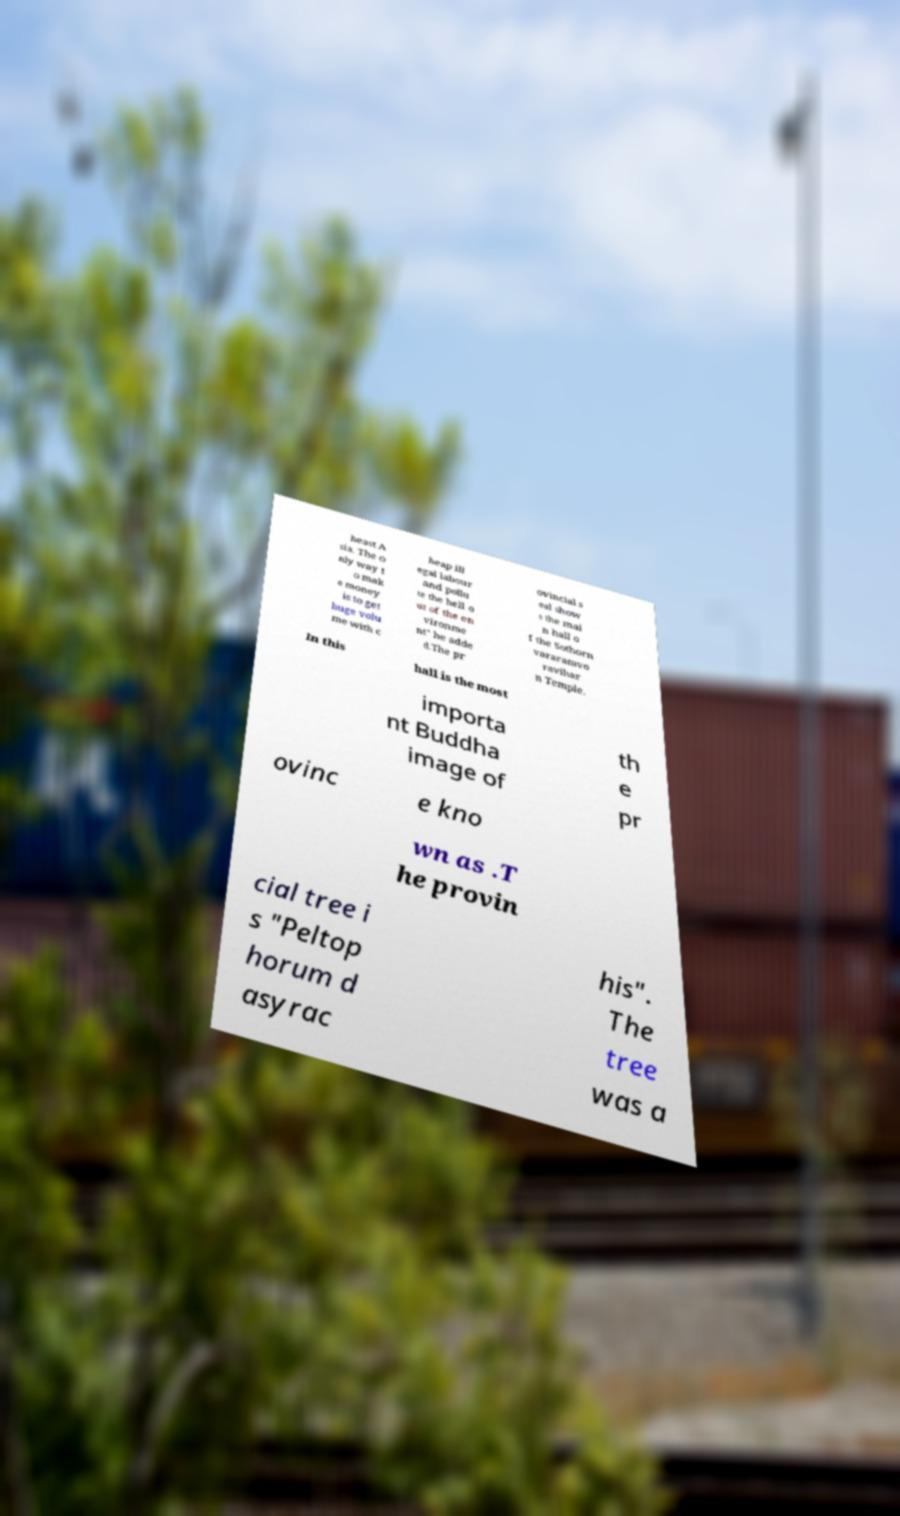Please identify and transcribe the text found in this image. heast A sia. The o nly way t o mak e money is to get huge volu me with c heap ill egal labour and pollu te the hell o ut of the en vironme nt" he adde d.The pr ovincial s eal show s the mai n hall o f the Sothorn vararamvo ravihar n Temple. In this hall is the most importa nt Buddha image of th e pr ovinc e kno wn as .T he provin cial tree i s "Peltop horum d asyrac his". The tree was a 